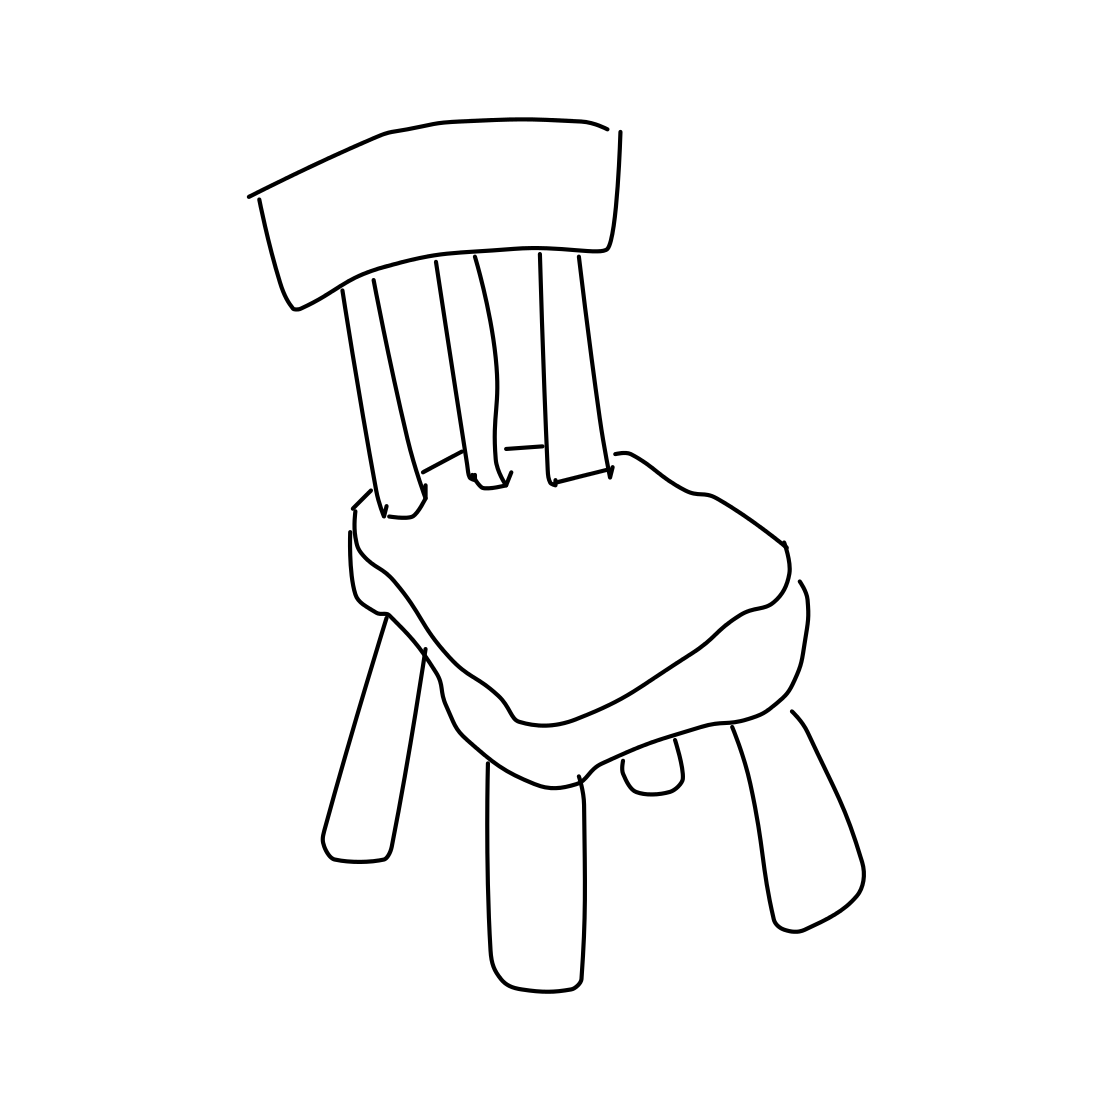Could this chair design be comfortable to sit on? Why or why not? From the sketch, it’s hard to conclusively say if the chair would be comfortable as details on material and padding are not visible. However, the seat appears to have a basic cushion shape which might offer some level of comfort. The design seems straightforward, with no ergonomic features apparent, which might affect comfort during prolonged use. 